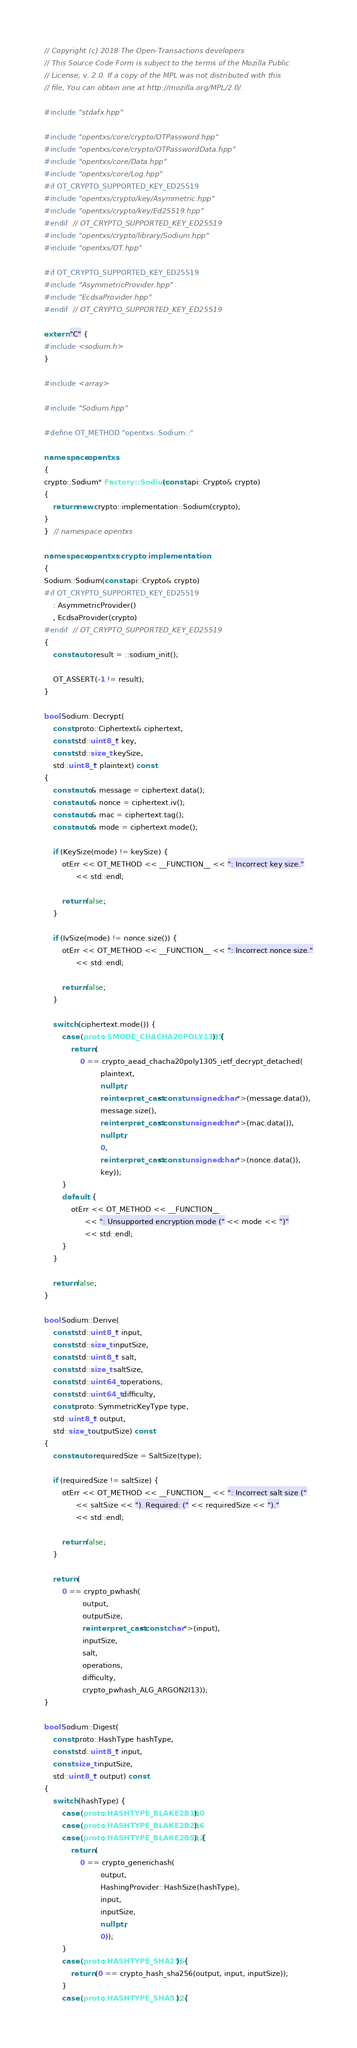Convert code to text. <code><loc_0><loc_0><loc_500><loc_500><_C++_>// Copyright (c) 2018 The Open-Transactions developers
// This Source Code Form is subject to the terms of the Mozilla Public
// License, v. 2.0. If a copy of the MPL was not distributed with this
// file, You can obtain one at http://mozilla.org/MPL/2.0/.

#include "stdafx.hpp"

#include "opentxs/core/crypto/OTPassword.hpp"
#include "opentxs/core/crypto/OTPasswordData.hpp"
#include "opentxs/core/Data.hpp"
#include "opentxs/core/Log.hpp"
#if OT_CRYPTO_SUPPORTED_KEY_ED25519
#include "opentxs/crypto/key/Asymmetric.hpp"
#include "opentxs/crypto/key/Ed25519.hpp"
#endif  // OT_CRYPTO_SUPPORTED_KEY_ED25519
#include "opentxs/crypto/library/Sodium.hpp"
#include "opentxs/OT.hpp"

#if OT_CRYPTO_SUPPORTED_KEY_ED25519
#include "AsymmetricProvider.hpp"
#include "EcdsaProvider.hpp"
#endif  // OT_CRYPTO_SUPPORTED_KEY_ED25519

extern "C" {
#include <sodium.h>
}

#include <array>

#include "Sodium.hpp"

#define OT_METHOD "opentxs::Sodium::"

namespace opentxs
{
crypto::Sodium* Factory::Sodium(const api::Crypto& crypto)
{
    return new crypto::implementation::Sodium(crypto);
}
}  // namespace opentxs

namespace opentxs::crypto::implementation
{
Sodium::Sodium(const api::Crypto& crypto)
#if OT_CRYPTO_SUPPORTED_KEY_ED25519
    : AsymmetricProvider()
    , EcdsaProvider(crypto)
#endif  // OT_CRYPTO_SUPPORTED_KEY_ED25519
{
    const auto result = ::sodium_init();

    OT_ASSERT(-1 != result);
}

bool Sodium::Decrypt(
    const proto::Ciphertext& ciphertext,
    const std::uint8_t* key,
    const std::size_t keySize,
    std::uint8_t* plaintext) const
{
    const auto& message = ciphertext.data();
    const auto& nonce = ciphertext.iv();
    const auto& mac = ciphertext.tag();
    const auto& mode = ciphertext.mode();

    if (KeySize(mode) != keySize) {
        otErr << OT_METHOD << __FUNCTION__ << ": Incorrect key size."
              << std::endl;

        return false;
    }

    if (IvSize(mode) != nonce.size()) {
        otErr << OT_METHOD << __FUNCTION__ << ": Incorrect nonce size."
              << std::endl;

        return false;
    }

    switch (ciphertext.mode()) {
        case (proto::SMODE_CHACHA20POLY1305): {
            return (
                0 == crypto_aead_chacha20poly1305_ietf_decrypt_detached(
                         plaintext,
                         nullptr,
                         reinterpret_cast<const unsigned char*>(message.data()),
                         message.size(),
                         reinterpret_cast<const unsigned char*>(mac.data()),
                         nullptr,
                         0,
                         reinterpret_cast<const unsigned char*>(nonce.data()),
                         key));
        }
        default: {
            otErr << OT_METHOD << __FUNCTION__
                  << ": Unsupported encryption mode (" << mode << ")"
                  << std::endl;
        }
    }

    return false;
}

bool Sodium::Derive(
    const std::uint8_t* input,
    const std::size_t inputSize,
    const std::uint8_t* salt,
    const std::size_t saltSize,
    const std::uint64_t operations,
    const std::uint64_t difficulty,
    const proto::SymmetricKeyType type,
    std::uint8_t* output,
    std::size_t outputSize) const
{
    const auto requiredSize = SaltSize(type);

    if (requiredSize != saltSize) {
        otErr << OT_METHOD << __FUNCTION__ << ": Incorrect salt size ("
              << saltSize << "). Required: (" << requiredSize << ")."
              << std::endl;

        return false;
    }

    return (
        0 == crypto_pwhash(
                 output,
                 outputSize,
                 reinterpret_cast<const char*>(input),
                 inputSize,
                 salt,
                 operations,
                 difficulty,
                 crypto_pwhash_ALG_ARGON2I13));
}

bool Sodium::Digest(
    const proto::HashType hashType,
    const std::uint8_t* input,
    const size_t inputSize,
    std::uint8_t* output) const
{
    switch (hashType) {
        case (proto::HASHTYPE_BLAKE2B160):
        case (proto::HASHTYPE_BLAKE2B256):
        case (proto::HASHTYPE_BLAKE2B512): {
            return (
                0 == crypto_generichash(
                         output,
                         HashingProvider::HashSize(hashType),
                         input,
                         inputSize,
                         nullptr,
                         0));
        }
        case (proto::HASHTYPE_SHA256): {
            return (0 == crypto_hash_sha256(output, input, inputSize));
        }
        case (proto::HASHTYPE_SHA512): {</code> 